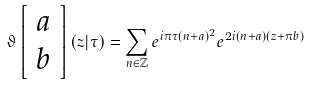<formula> <loc_0><loc_0><loc_500><loc_500>\vartheta \left [ \begin{array} { c } a \\ b \end{array} \right ] ( z | \tau ) = \sum _ { n \in \mathbb { Z } } e ^ { i \pi \tau ( n + a ) ^ { 2 } } e ^ { 2 i ( n + a ) ( z + \pi b ) }</formula> 